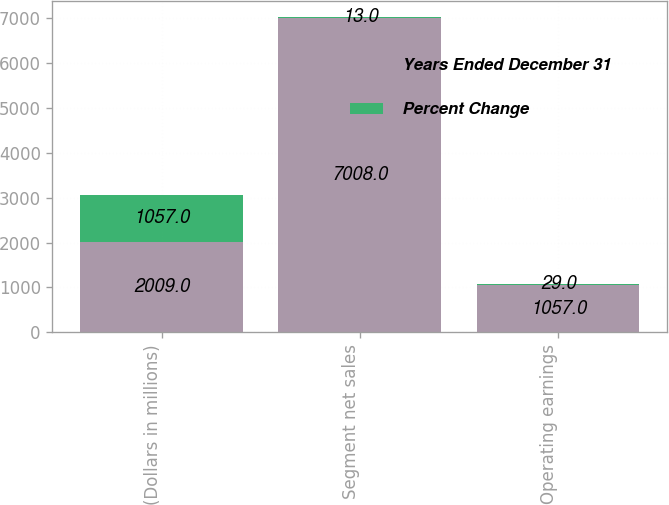Convert chart to OTSL. <chart><loc_0><loc_0><loc_500><loc_500><stacked_bar_chart><ecel><fcel>(Dollars in millions)<fcel>Segment net sales<fcel>Operating earnings<nl><fcel>Years Ended December 31<fcel>2009<fcel>7008<fcel>1057<nl><fcel>Percent Change<fcel>1057<fcel>13<fcel>29<nl></chart> 